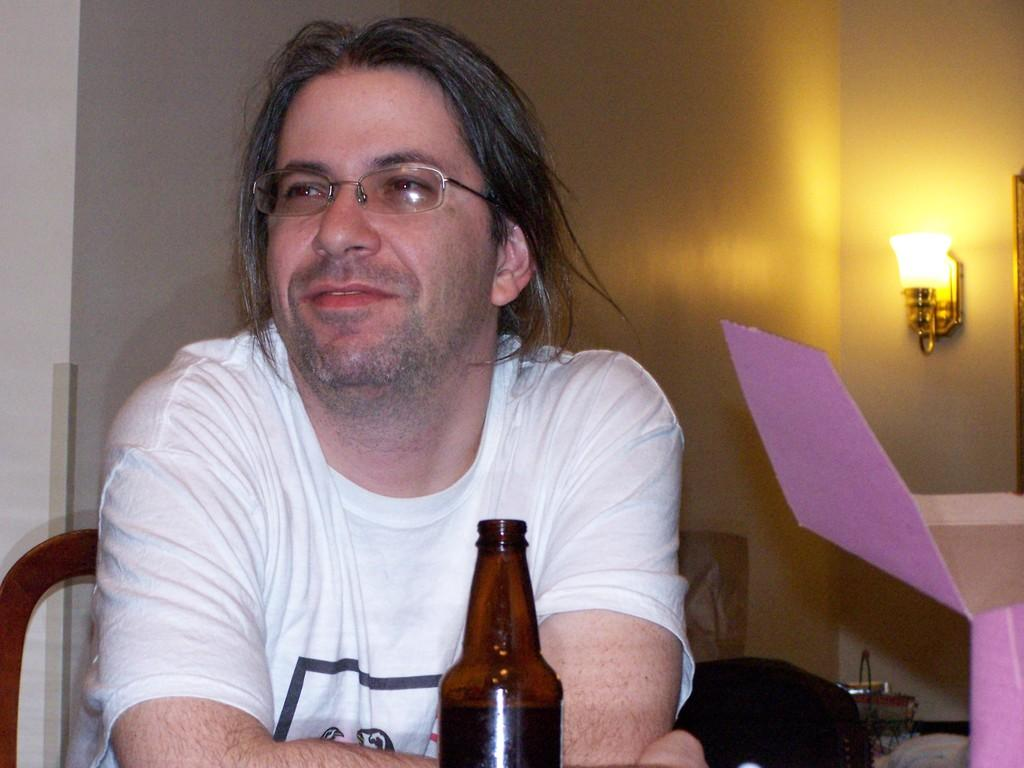Who is present in the image? There is a man in the image. What is the man doing in the image? The man is sitting on a chair. Where is the man located in the image? The man is on the left side of the image. What expression does the man have in the image? The man is smiling. What can be seen in the background of the image? There is a light fixed to a wall in the background of the image. What action is the man taking to prevent death in the image? There is no indication of death or any action related to preventing it in the image. 